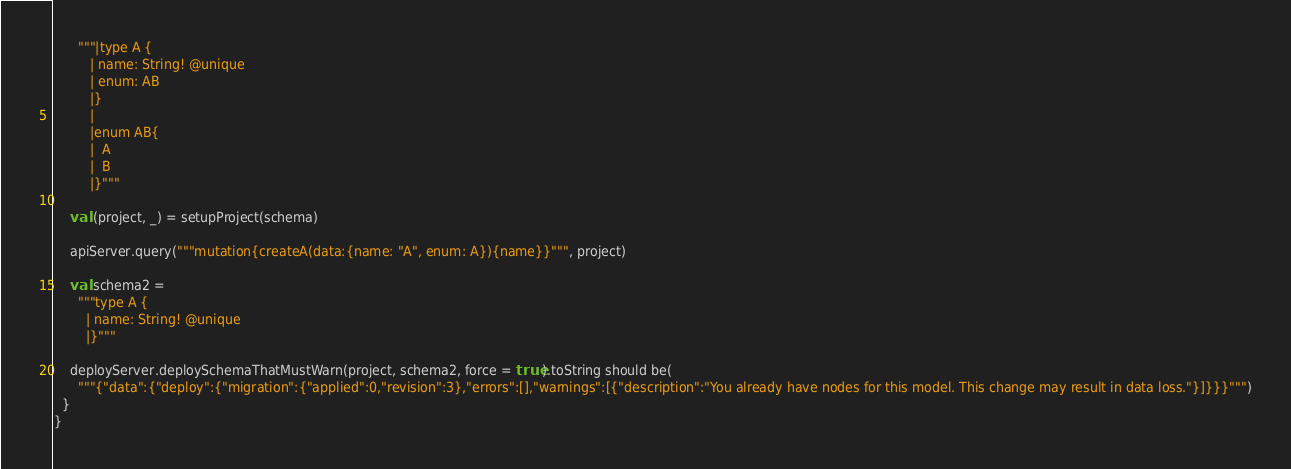<code> <loc_0><loc_0><loc_500><loc_500><_Scala_>      """|type A {
         | name: String! @unique
         | enum: AB
         |}
         |
         |enum AB{
         |  A
         |  B
         |}"""

    val (project, _) = setupProject(schema)

    apiServer.query("""mutation{createA(data:{name: "A", enum: A}){name}}""", project)

    val schema2 =
      """type A {
        | name: String! @unique
        |}"""

    deployServer.deploySchemaThatMustWarn(project, schema2, force = true).toString should be(
      """{"data":{"deploy":{"migration":{"applied":0,"revision":3},"errors":[],"warnings":[{"description":"You already have nodes for this model. This change may result in data loss."}]}}}""")
  }
}
</code> 